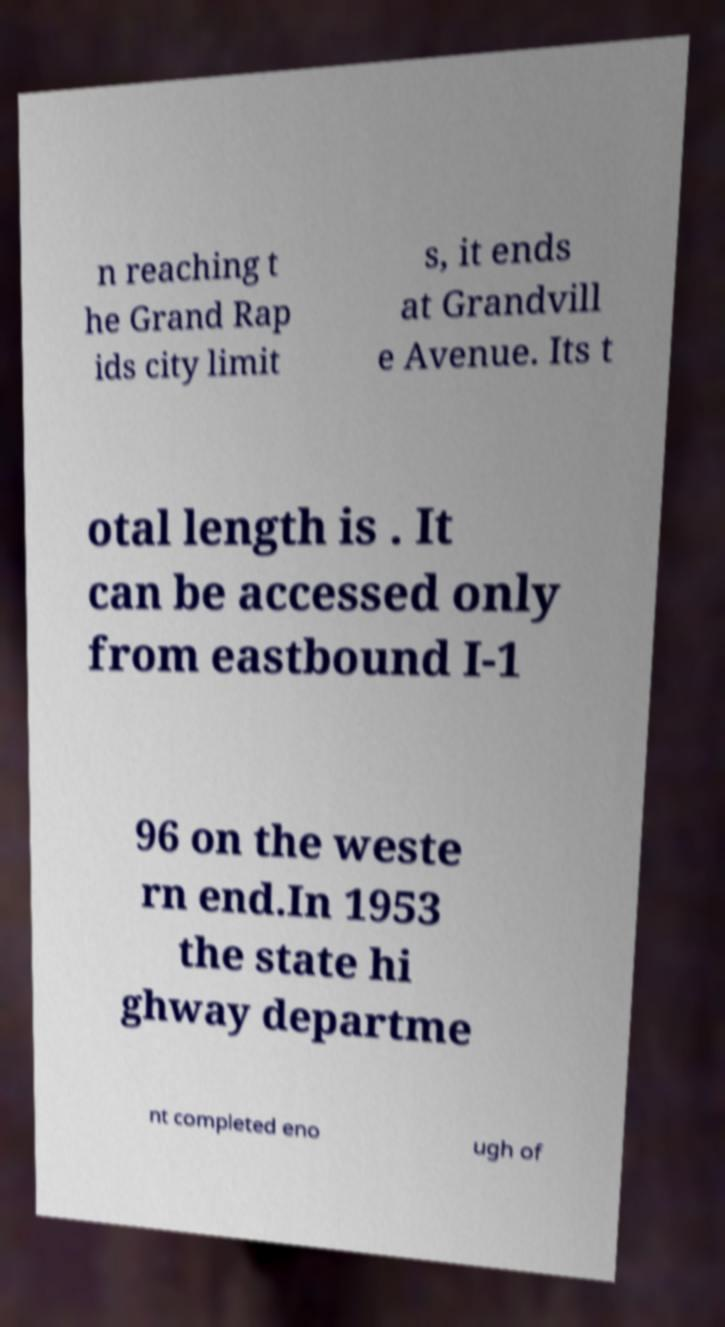Please identify and transcribe the text found in this image. n reaching t he Grand Rap ids city limit s, it ends at Grandvill e Avenue. Its t otal length is . It can be accessed only from eastbound I-1 96 on the weste rn end.In 1953 the state hi ghway departme nt completed eno ugh of 